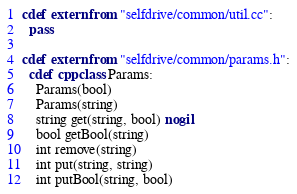<code> <loc_0><loc_0><loc_500><loc_500><_Cython_>
cdef extern from "selfdrive/common/util.cc":
  pass

cdef extern from "selfdrive/common/params.h":
  cdef cppclass Params:
    Params(bool)
    Params(string)
    string get(string, bool) nogil
    bool getBool(string)
    int remove(string)
    int put(string, string)
    int putBool(string, bool)
</code> 